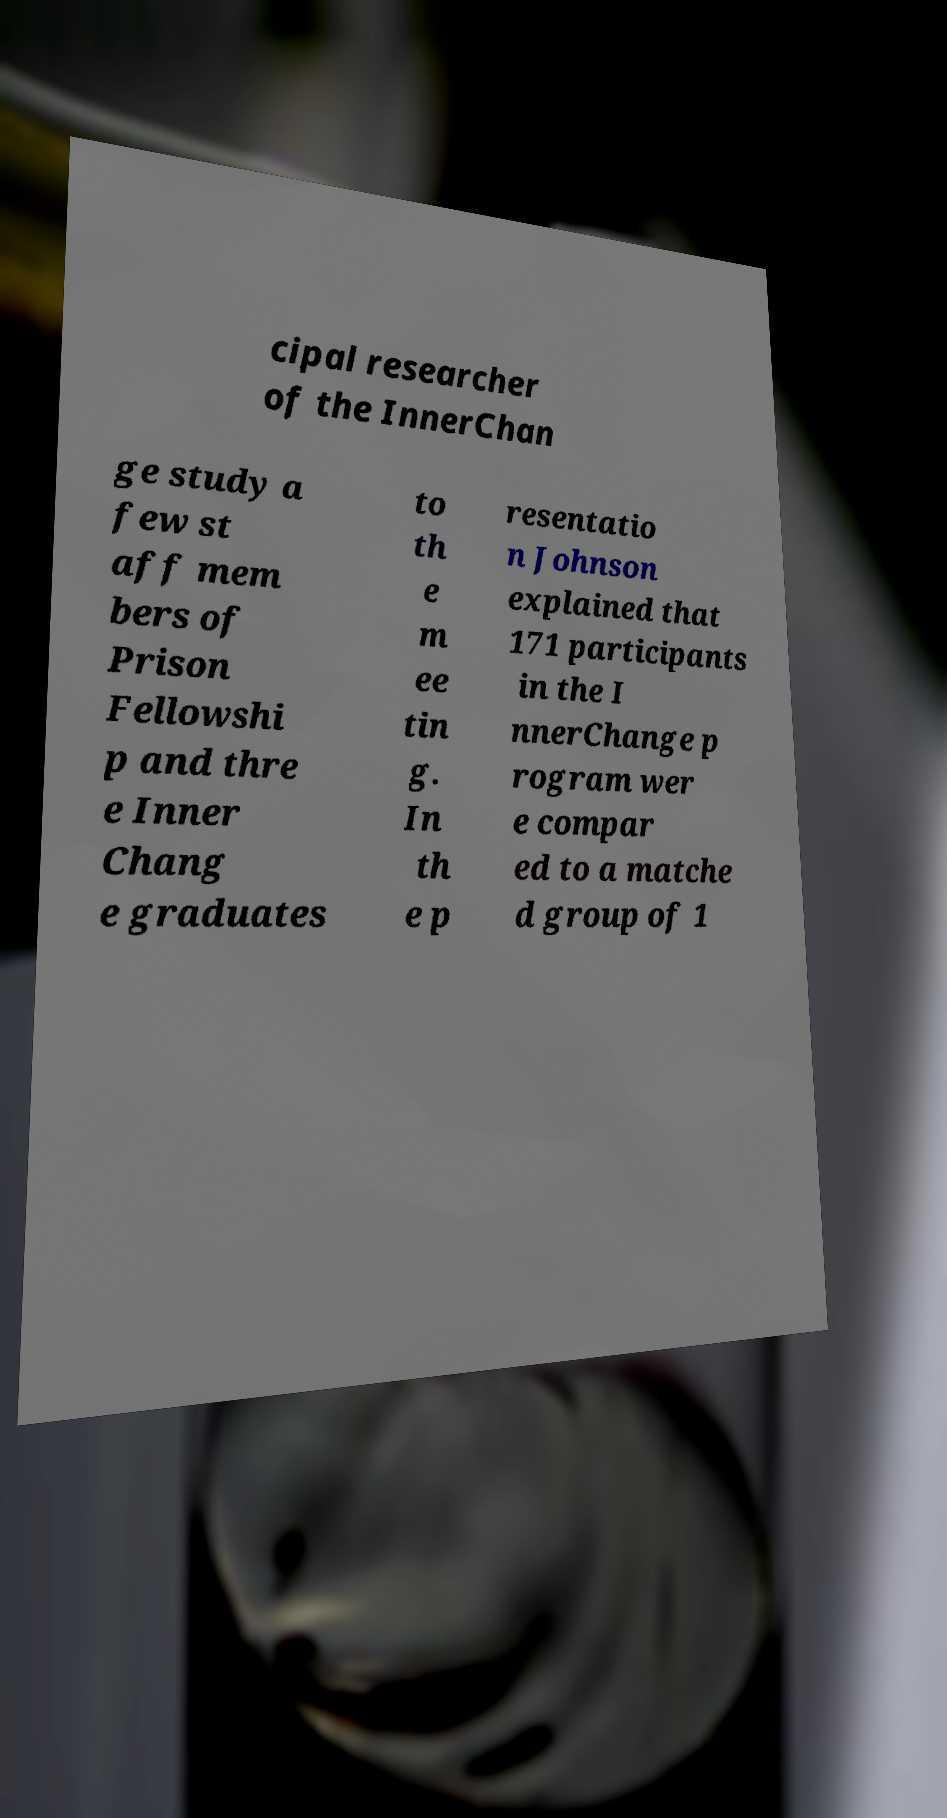For documentation purposes, I need the text within this image transcribed. Could you provide that? cipal researcher of the InnerChan ge study a few st aff mem bers of Prison Fellowshi p and thre e Inner Chang e graduates to th e m ee tin g. In th e p resentatio n Johnson explained that 171 participants in the I nnerChange p rogram wer e compar ed to a matche d group of 1 